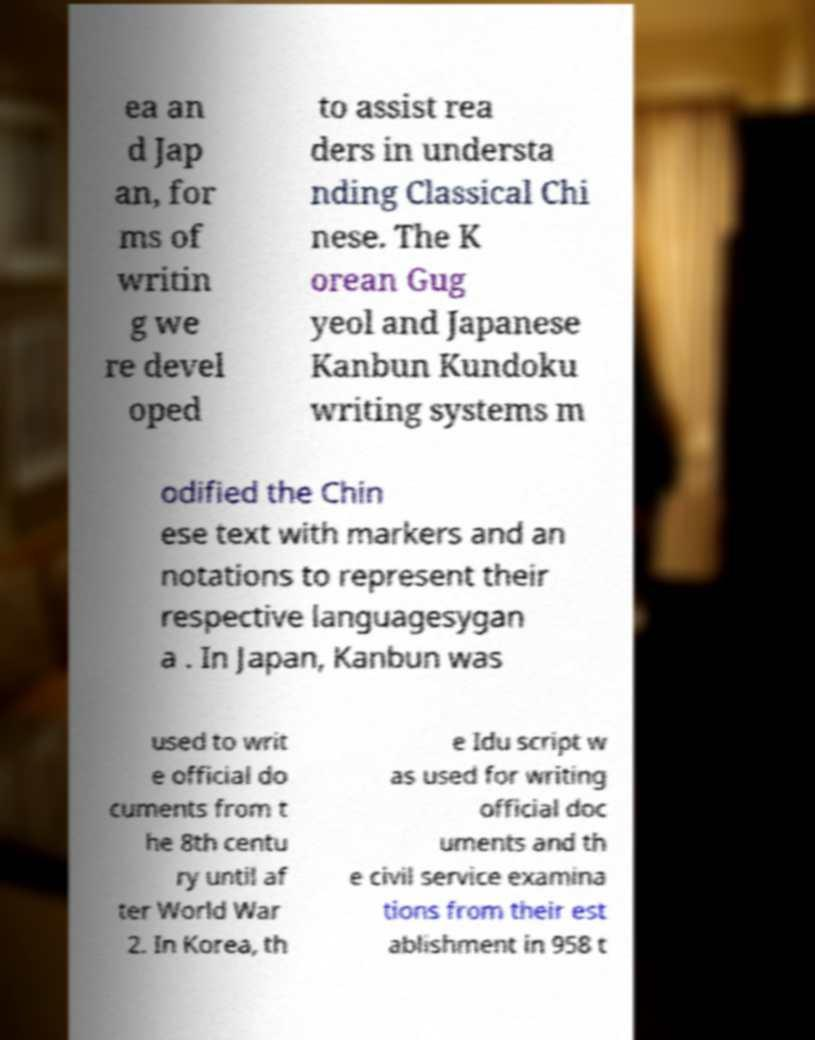Please read and relay the text visible in this image. What does it say? ea an d Jap an, for ms of writin g we re devel oped to assist rea ders in understa nding Classical Chi nese. The K orean Gug yeol and Japanese Kanbun Kundoku writing systems m odified the Chin ese text with markers and an notations to represent their respective languagesygan a . In Japan, Kanbun was used to writ e official do cuments from t he 8th centu ry until af ter World War 2. In Korea, th e Idu script w as used for writing official doc uments and th e civil service examina tions from their est ablishment in 958 t 